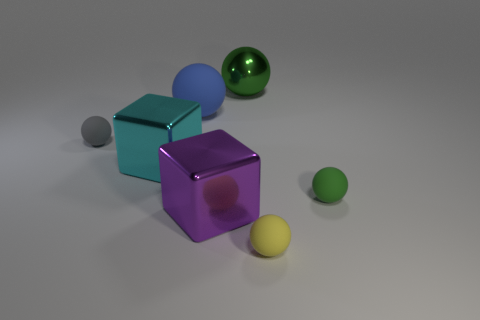How many large spheres are the same material as the cyan object?
Give a very brief answer. 1. Are the green object that is to the left of the yellow ball and the big purple cube made of the same material?
Make the answer very short. Yes. Is the number of small green things behind the gray rubber ball greater than the number of purple shiny things that are in front of the purple shiny block?
Make the answer very short. No. There is a gray sphere that is the same size as the yellow matte ball; what material is it?
Your answer should be compact. Rubber. What number of other objects are there of the same material as the purple object?
Provide a succinct answer. 2. There is a small rubber thing behind the green rubber thing; does it have the same shape as the large shiny object that is in front of the large cyan shiny object?
Provide a short and direct response. No. What number of other objects are there of the same color as the metallic sphere?
Ensure brevity in your answer.  1. Is the green sphere that is behind the tiny gray ball made of the same material as the tiny object that is to the right of the yellow matte thing?
Offer a very short reply. No. Are there the same number of objects that are in front of the small green matte ball and large cubes that are behind the tiny gray object?
Keep it short and to the point. No. What is the big ball that is to the right of the large purple block made of?
Make the answer very short. Metal. 